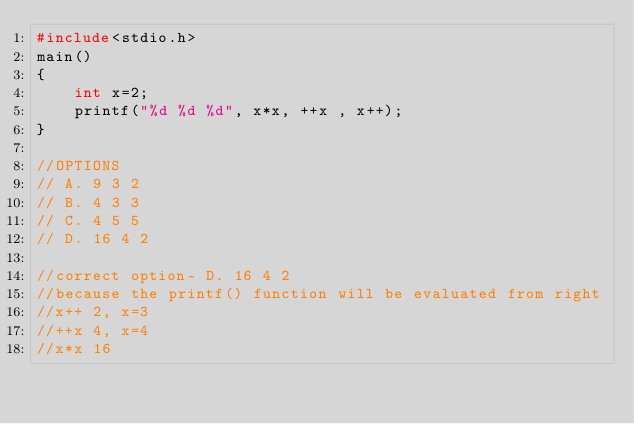<code> <loc_0><loc_0><loc_500><loc_500><_C_>#include<stdio.h>
main()
{
    int x=2;
    printf("%d %d %d", x*x, ++x , x++);
}

//OPTIONS
// A. 9 3 2
// B. 4 3 3
// C. 4 5 5
// D. 16 4 2

//correct option- D. 16 4 2
//because the printf() function will be evaluated from right
//x++ 2, x=3
//++x 4, x=4
//x*x 16
</code> 